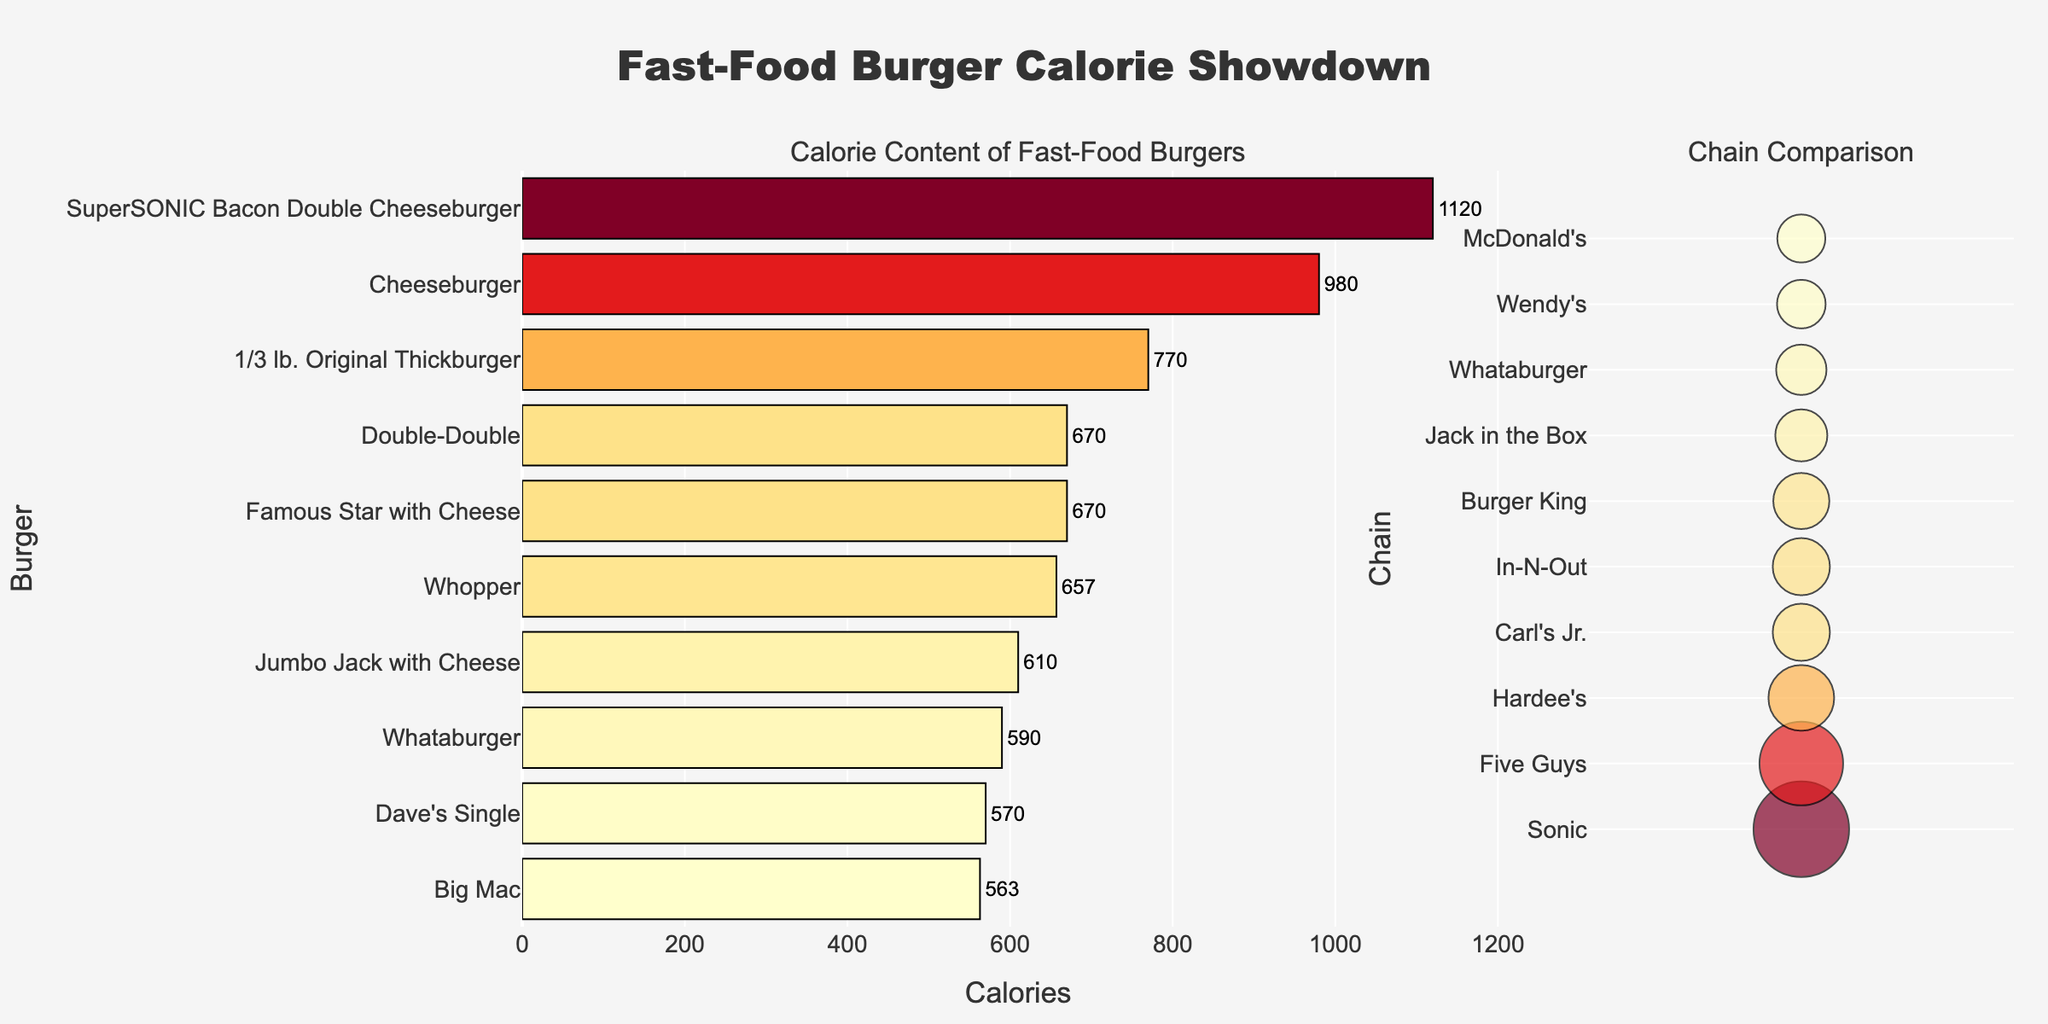Which author has the lowest Average Word Length? By referring to the 'Average Word Length' subplot, the author bars are visually compared. The lowest value is observed for Dan Brown from the Contemporary era.
Answer: Dan Brown How many unique words per 1000 does Jane Austen have? In the 'Unique Words per 1000' subplot, Jane Austen's bar shows her respective value.
Answer: 165 Which era tends to have higher readability scores? By comparing the average bar lengths in the 'Readability Score' subplot for Classic and Contemporary groups, it's seen that Contemporary authors generally have higher readability scores.
Answer: Contemporary Among the Classic authors, who uses the most unique words per 1000? In the 'Unique Words per 1000' subplot, the Classic authors' bars are compared. William Shakespeare has the highest value.
Answer: William Shakespeare Which author from the Contemporary era has the highest readability score? The 'Readability Score' subplot is reviewed, and by comparing the Contemporary authors, Dan Brown shows the highest value.
Answer: Dan Brown What is the difference in Average Word Length between George Orwell and John Green? The 'Average Word Length' subplot shows values for George Orwell and John Green. George Orwell has 4.1 and John Green has 3.9, resulting in a difference of 4.1 - 3.9 = 0.2.
Answer: 0.2 Which author has the highest Unique Words per 1000 in the Contemporary era? By looking at the 'Unique Words per 1000' subplot and checking the Contemporary bars, J.K. Rowling has the highest unique words per 1000.
Answer: J.K. Rowling Do Classic or Contemporary authors generally use longer average word lengths? The 'Average Word Length' subplot shows Classic authors having longer word lengths.
Answer: Classic What is the average Readability Score for Classic authors? Sum the 'Readability Score' values for Classic authors: 65 + 70 + 68 + 75 + 72 = 350. Divide by 5 to get the average: 350 / 5 = 70.
Answer: 70 